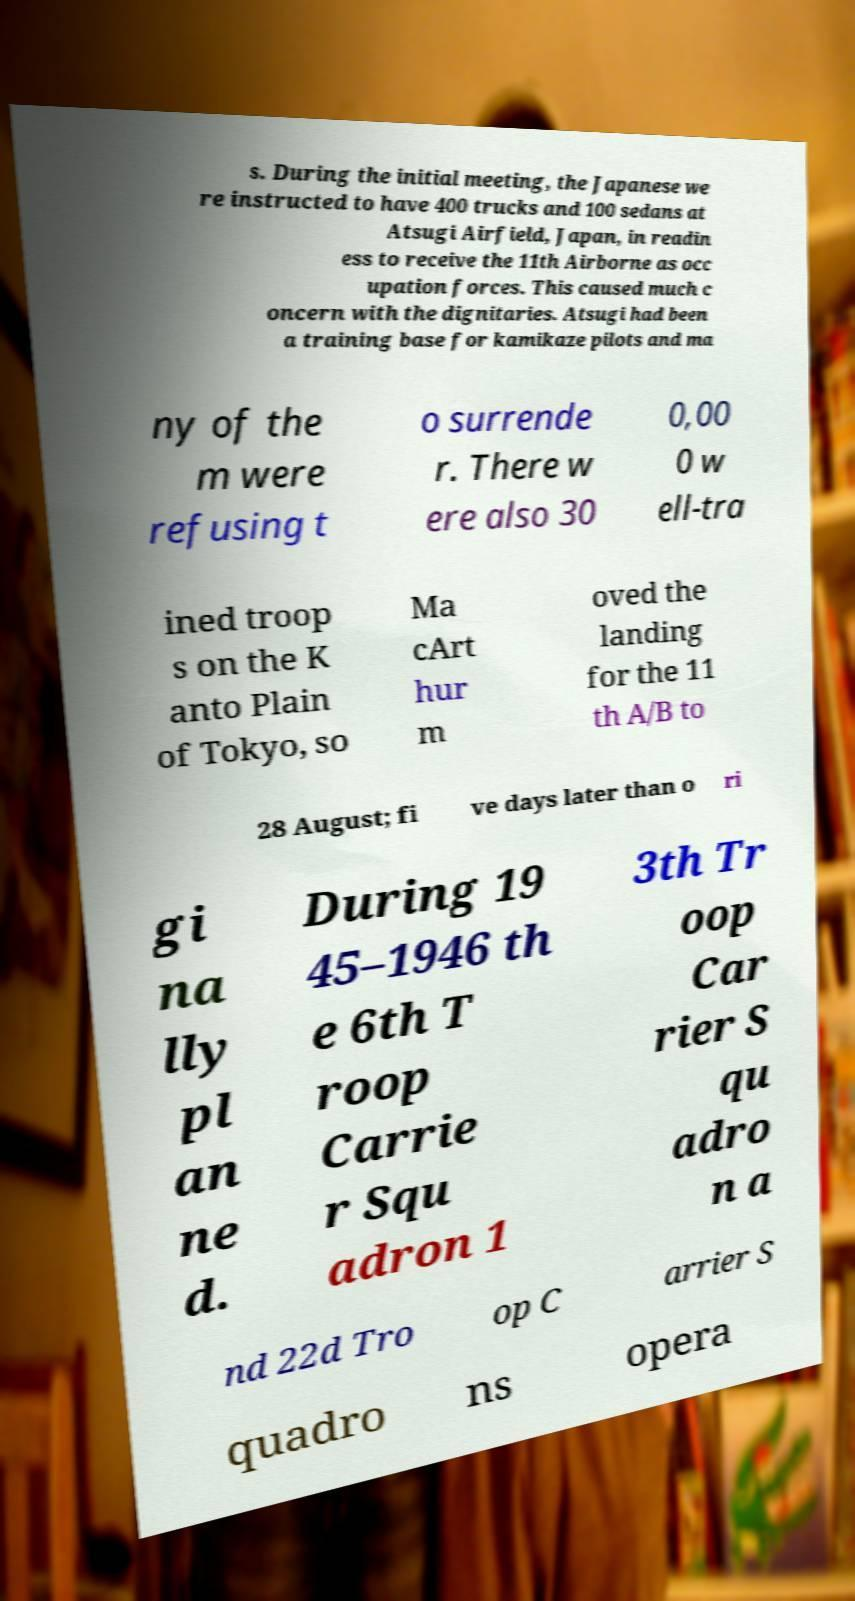Could you extract and type out the text from this image? s. During the initial meeting, the Japanese we re instructed to have 400 trucks and 100 sedans at Atsugi Airfield, Japan, in readin ess to receive the 11th Airborne as occ upation forces. This caused much c oncern with the dignitaries. Atsugi had been a training base for kamikaze pilots and ma ny of the m were refusing t o surrende r. There w ere also 30 0,00 0 w ell-tra ined troop s on the K anto Plain of Tokyo, so Ma cArt hur m oved the landing for the 11 th A/B to 28 August; fi ve days later than o ri gi na lly pl an ne d. During 19 45–1946 th e 6th T roop Carrie r Squ adron 1 3th Tr oop Car rier S qu adro n a nd 22d Tro op C arrier S quadro ns opera 